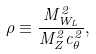<formula> <loc_0><loc_0><loc_500><loc_500>\rho \equiv \frac { M _ { W _ { L } } ^ { 2 } } { M _ { Z } ^ { 2 } c _ { \theta } ^ { 2 } } ,</formula> 